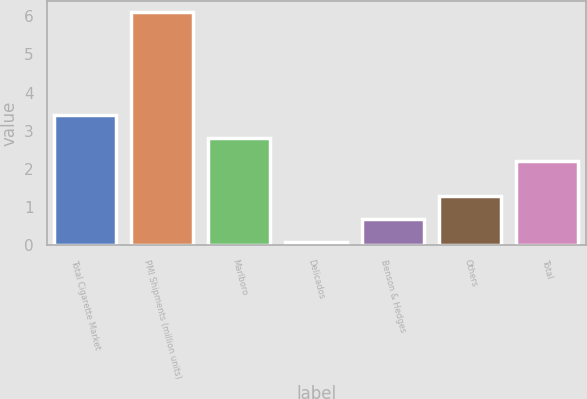<chart> <loc_0><loc_0><loc_500><loc_500><bar_chart><fcel>Total Cigarette Market<fcel>PMI Shipments (million units)<fcel>Marlboro<fcel>Delicados<fcel>Benson & Hedges<fcel>Others<fcel>Total<nl><fcel>3.4<fcel>6.1<fcel>2.8<fcel>0.1<fcel>0.7<fcel>1.3<fcel>2.2<nl></chart> 